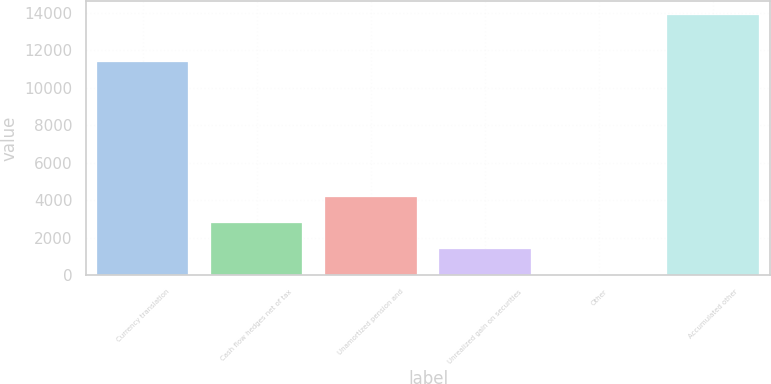Convert chart to OTSL. <chart><loc_0><loc_0><loc_500><loc_500><bar_chart><fcel>Currency translation<fcel>Cash flow hedges net of tax<fcel>Unamortized pension and<fcel>Unrealized gain on securities<fcel>Other<fcel>Accumulated other<nl><fcel>11386<fcel>2811.8<fcel>4200.2<fcel>1423.4<fcel>35<fcel>13919<nl></chart> 